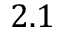Convert formula to latex. <formula><loc_0><loc_0><loc_500><loc_500>2 . 1</formula> 